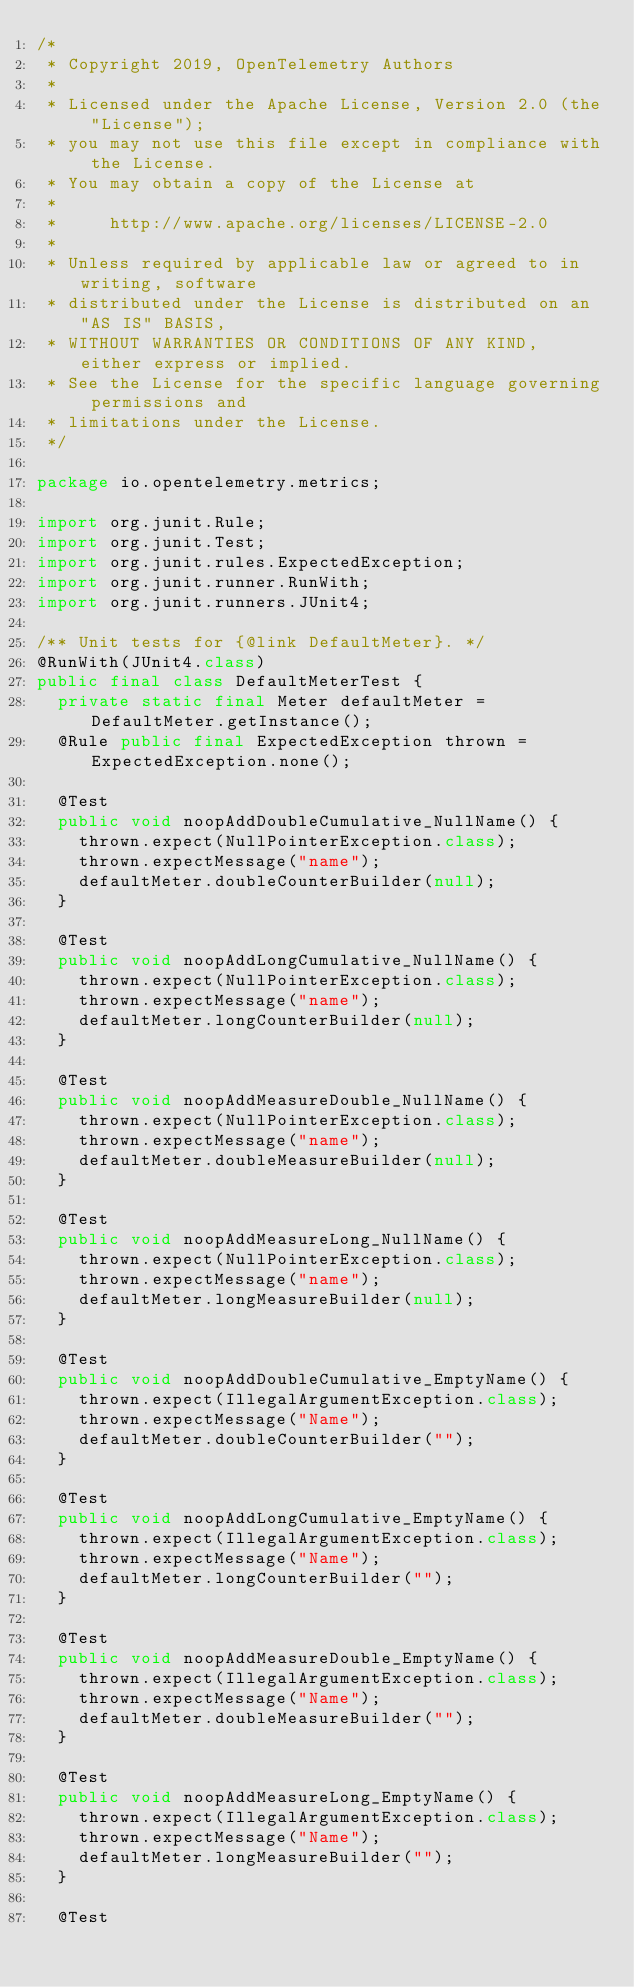<code> <loc_0><loc_0><loc_500><loc_500><_Java_>/*
 * Copyright 2019, OpenTelemetry Authors
 *
 * Licensed under the Apache License, Version 2.0 (the "License");
 * you may not use this file except in compliance with the License.
 * You may obtain a copy of the License at
 *
 *     http://www.apache.org/licenses/LICENSE-2.0
 *
 * Unless required by applicable law or agreed to in writing, software
 * distributed under the License is distributed on an "AS IS" BASIS,
 * WITHOUT WARRANTIES OR CONDITIONS OF ANY KIND, either express or implied.
 * See the License for the specific language governing permissions and
 * limitations under the License.
 */

package io.opentelemetry.metrics;

import org.junit.Rule;
import org.junit.Test;
import org.junit.rules.ExpectedException;
import org.junit.runner.RunWith;
import org.junit.runners.JUnit4;

/** Unit tests for {@link DefaultMeter}. */
@RunWith(JUnit4.class)
public final class DefaultMeterTest {
  private static final Meter defaultMeter = DefaultMeter.getInstance();
  @Rule public final ExpectedException thrown = ExpectedException.none();

  @Test
  public void noopAddDoubleCumulative_NullName() {
    thrown.expect(NullPointerException.class);
    thrown.expectMessage("name");
    defaultMeter.doubleCounterBuilder(null);
  }

  @Test
  public void noopAddLongCumulative_NullName() {
    thrown.expect(NullPointerException.class);
    thrown.expectMessage("name");
    defaultMeter.longCounterBuilder(null);
  }

  @Test
  public void noopAddMeasureDouble_NullName() {
    thrown.expect(NullPointerException.class);
    thrown.expectMessage("name");
    defaultMeter.doubleMeasureBuilder(null);
  }

  @Test
  public void noopAddMeasureLong_NullName() {
    thrown.expect(NullPointerException.class);
    thrown.expectMessage("name");
    defaultMeter.longMeasureBuilder(null);
  }

  @Test
  public void noopAddDoubleCumulative_EmptyName() {
    thrown.expect(IllegalArgumentException.class);
    thrown.expectMessage("Name");
    defaultMeter.doubleCounterBuilder("");
  }

  @Test
  public void noopAddLongCumulative_EmptyName() {
    thrown.expect(IllegalArgumentException.class);
    thrown.expectMessage("Name");
    defaultMeter.longCounterBuilder("");
  }

  @Test
  public void noopAddMeasureDouble_EmptyName() {
    thrown.expect(IllegalArgumentException.class);
    thrown.expectMessage("Name");
    defaultMeter.doubleMeasureBuilder("");
  }

  @Test
  public void noopAddMeasureLong_EmptyName() {
    thrown.expect(IllegalArgumentException.class);
    thrown.expectMessage("Name");
    defaultMeter.longMeasureBuilder("");
  }

  @Test</code> 